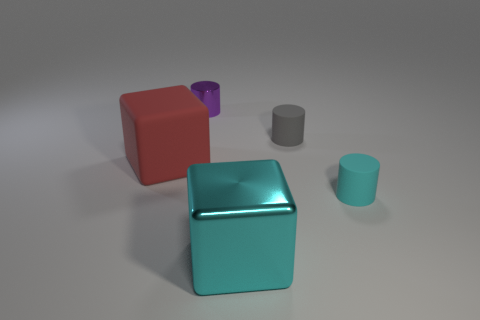Are there fewer small gray matte things than rubber things?
Provide a short and direct response. Yes. What material is the other cube that is the same size as the shiny block?
Offer a very short reply. Rubber. Is the number of tiny red matte spheres greater than the number of purple things?
Keep it short and to the point. No. What number of other objects are there of the same color as the large matte block?
Your response must be concise. 0. How many cyan objects are in front of the tiny cyan object and behind the shiny cube?
Give a very brief answer. 0. Is there anything else that has the same size as the gray rubber object?
Offer a terse response. Yes. Is the number of small metallic cylinders right of the big cyan metal block greater than the number of small things that are behind the tiny metal object?
Provide a succinct answer. No. What is the material of the block right of the shiny cylinder?
Your response must be concise. Metal. Is the shape of the small cyan rubber object the same as the metal object that is in front of the small gray thing?
Offer a very short reply. No. There is a shiny object in front of the tiny gray cylinder in front of the small metallic cylinder; how many big metal things are in front of it?
Offer a very short reply. 0. 